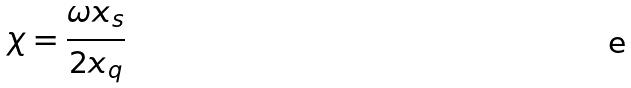Convert formula to latex. <formula><loc_0><loc_0><loc_500><loc_500>\chi = \frac { \omega x _ { s } } { 2 x _ { q } }</formula> 